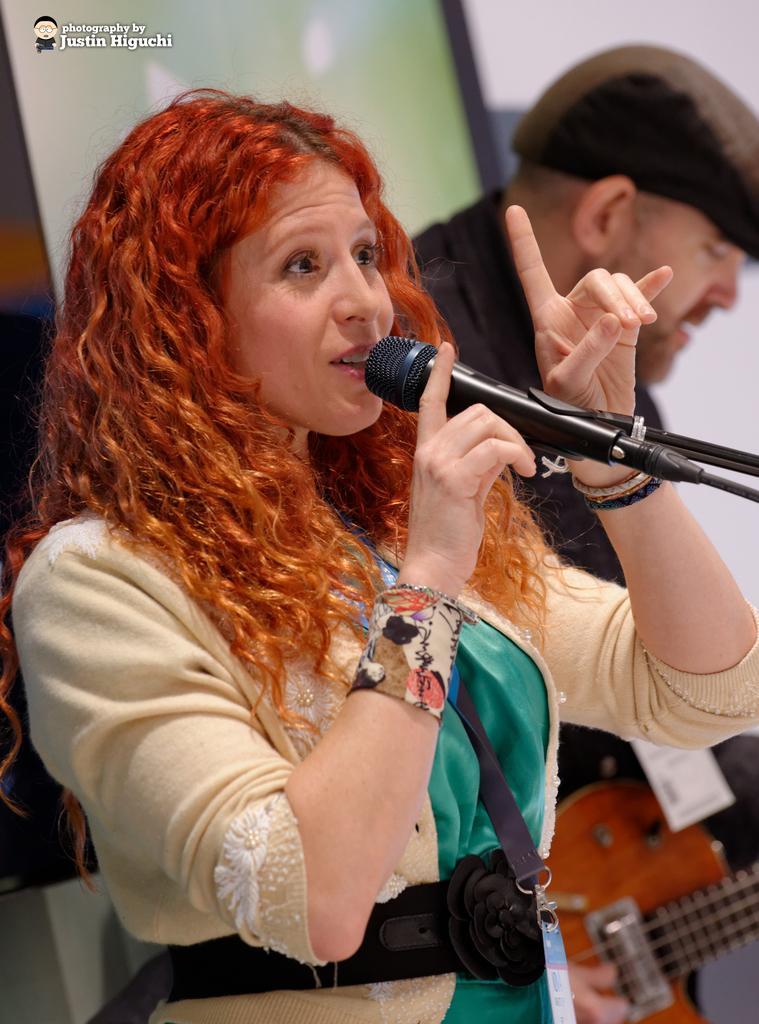How would you summarize this image in a sentence or two? This woman holds mic and talking. This woman wore a jacket. Far this person is playing a guitar and wore cap. 